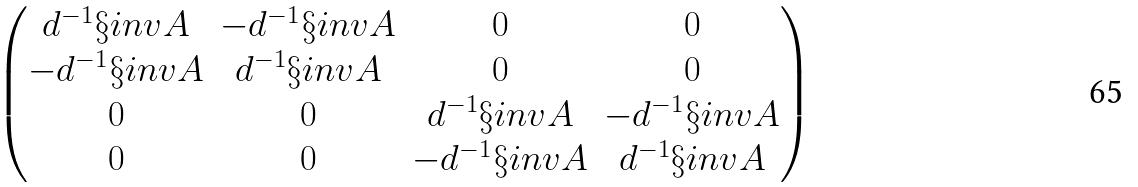Convert formula to latex. <formula><loc_0><loc_0><loc_500><loc_500>\begin{pmatrix} d ^ { - 1 } \S i n v { A } & - d ^ { - 1 } \S i n v { A } & 0 & 0 \\ - d ^ { - 1 } \S i n v { A } & d ^ { - 1 } \S i n v { A } & 0 & 0 \\ 0 & 0 & d ^ { - 1 } \S i n v { A } & - d ^ { - 1 } \S i n v { A } \\ 0 & 0 & - d ^ { - 1 } \S i n v { A } & d ^ { - 1 } \S i n v { A } \\ \end{pmatrix}</formula> 